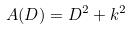Convert formula to latex. <formula><loc_0><loc_0><loc_500><loc_500>A ( D ) = D ^ { 2 } + k ^ { 2 }</formula> 